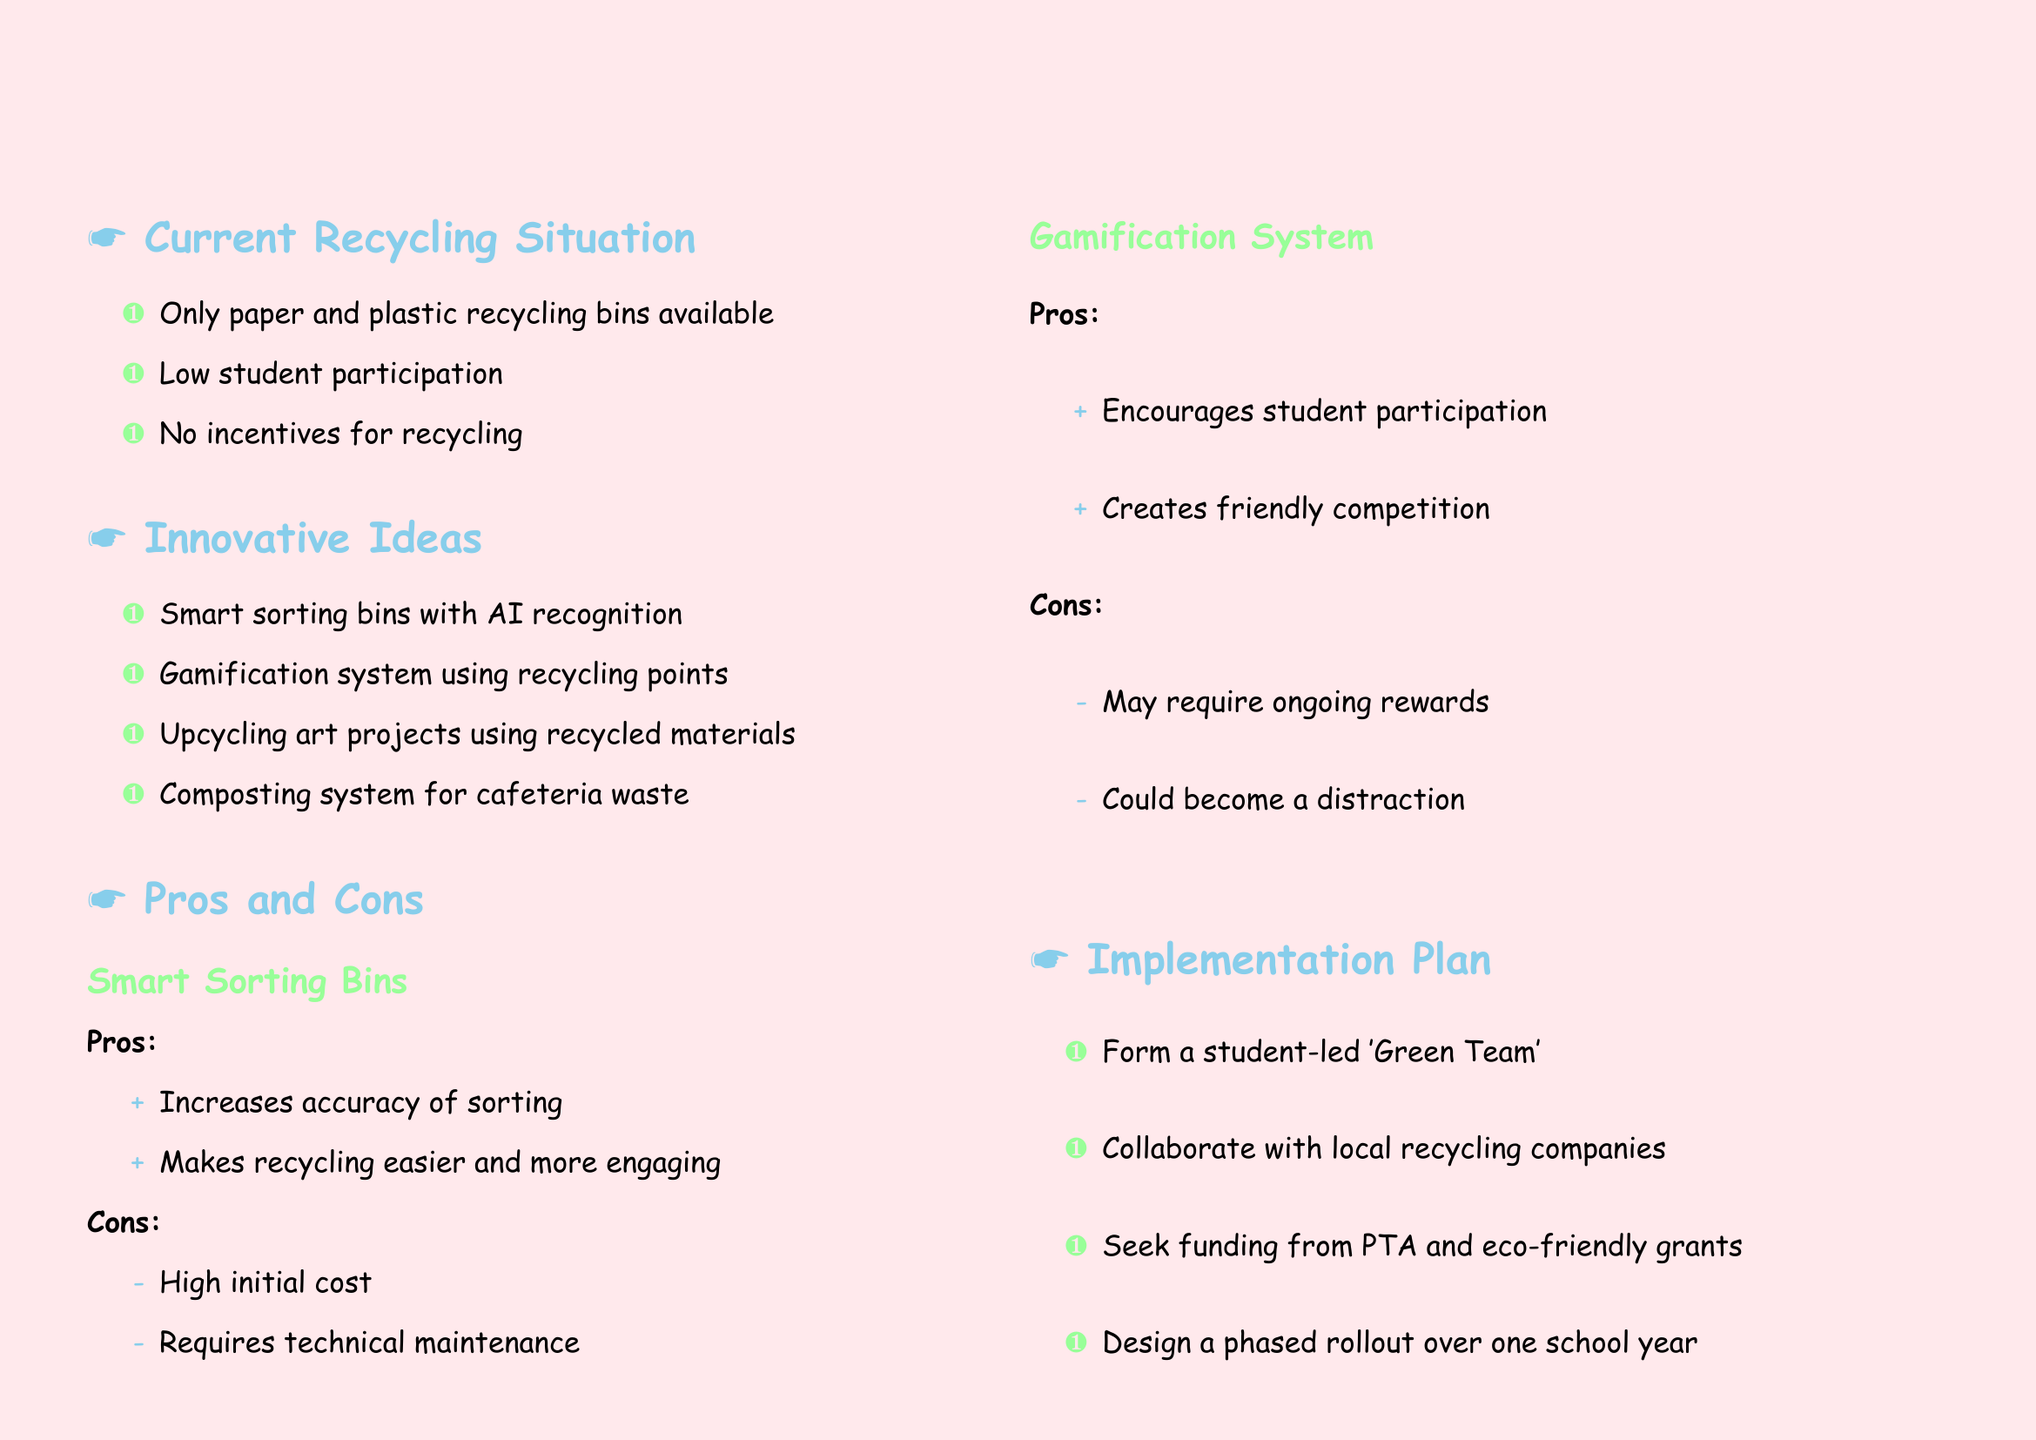What is the title of the document? The title of the document is the main heading that summarizes its content, which is "Innovative Recycling System for Our School."
Answer: Innovative Recycling System for Our School How many points are listed in the current recycling situation? The current recycling situation section contains three specific points, as outlined in the document.
Answer: 3 What is one innovative idea proposed for recycling? The document lists several innovative ideas, of which "Smart sorting bins with AI recognition" is one.
Answer: Smart sorting bins with AI recognition What is a pro of the gamification system? The document states several positive aspects of the gamification system, including that it "Encourages student participation."
Answer: Encourages student participation What is one con of smart sorting bins? The document mentions the con that smart sorting bins have a "High initial cost."
Answer: High initial cost What team should be formed according to the implementation plan? The implementation plan suggests forming a student-led team to oversee the recycling initiatives, referred to as the 'Green Team.'
Answer: Green Team What is the mascot idea proposed in the document? The document features a creative element describing a mascot, which is "Recycle Rex, a friendly dinosaur mascot made from recycled materials."
Answer: Recycle Rex What description is given for Recycle Rex? The document states that Recycle Rex is a "friendly dinosaur mascot made from recycled materials to promote the new system."
Answer: friendly dinosaur mascot made from recycled materials to promote the new system What should the next steps involve? The document outlines that the next steps include presenting ideas to the school board, which is a goal for moving forward.
Answer: Present our ideas to the school board 